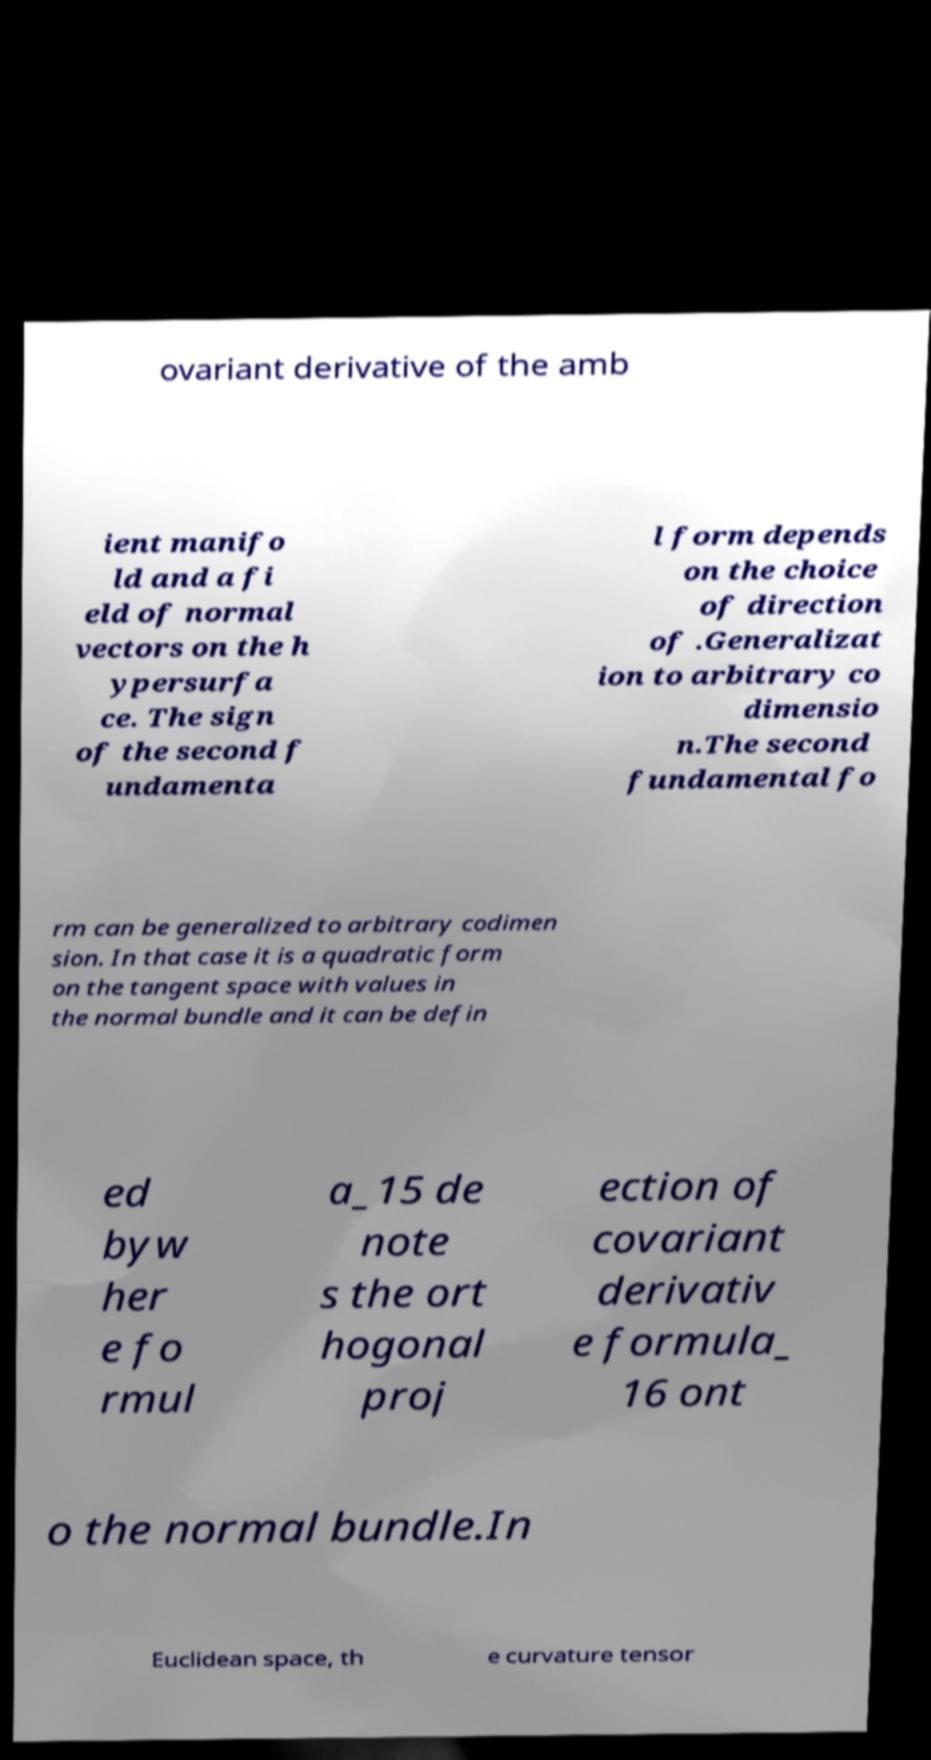Can you accurately transcribe the text from the provided image for me? ovariant derivative of the amb ient manifo ld and a fi eld of normal vectors on the h ypersurfa ce. The sign of the second f undamenta l form depends on the choice of direction of .Generalizat ion to arbitrary co dimensio n.The second fundamental fo rm can be generalized to arbitrary codimen sion. In that case it is a quadratic form on the tangent space with values in the normal bundle and it can be defin ed byw her e fo rmul a_15 de note s the ort hogonal proj ection of covariant derivativ e formula_ 16 ont o the normal bundle.In Euclidean space, th e curvature tensor 